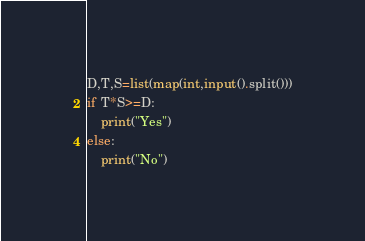<code> <loc_0><loc_0><loc_500><loc_500><_Python_>D,T,S=list(map(int,input().split()))
if T*S>=D:
    print("Yes")
else:
    print("No")</code> 